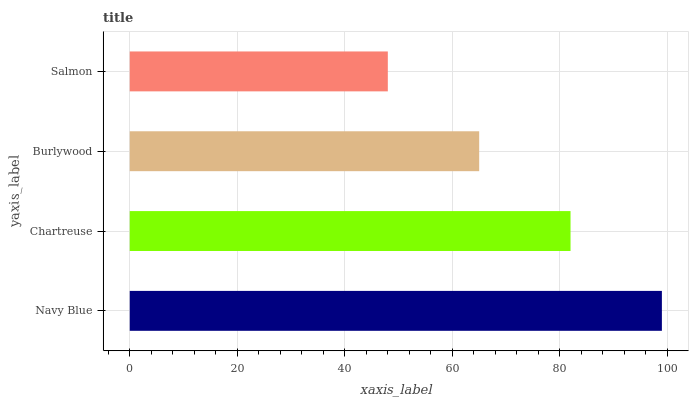Is Salmon the minimum?
Answer yes or no. Yes. Is Navy Blue the maximum?
Answer yes or no. Yes. Is Chartreuse the minimum?
Answer yes or no. No. Is Chartreuse the maximum?
Answer yes or no. No. Is Navy Blue greater than Chartreuse?
Answer yes or no. Yes. Is Chartreuse less than Navy Blue?
Answer yes or no. Yes. Is Chartreuse greater than Navy Blue?
Answer yes or no. No. Is Navy Blue less than Chartreuse?
Answer yes or no. No. Is Chartreuse the high median?
Answer yes or no. Yes. Is Burlywood the low median?
Answer yes or no. Yes. Is Navy Blue the high median?
Answer yes or no. No. Is Salmon the low median?
Answer yes or no. No. 